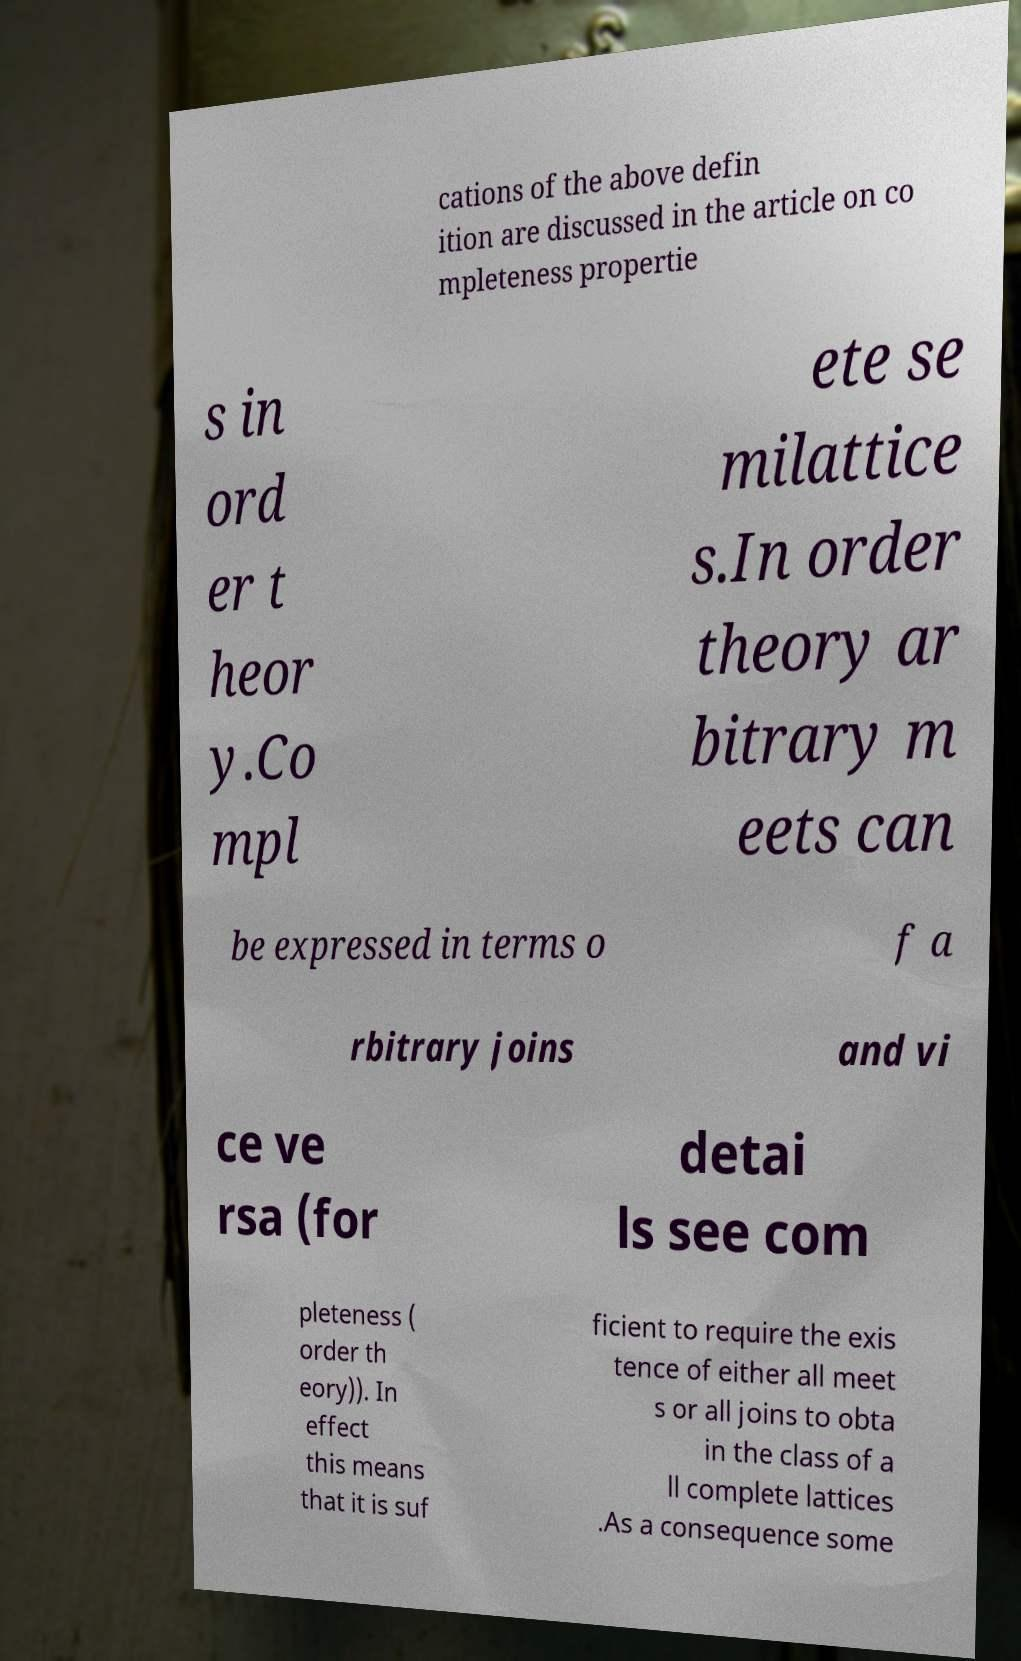For documentation purposes, I need the text within this image transcribed. Could you provide that? cations of the above defin ition are discussed in the article on co mpleteness propertie s in ord er t heor y.Co mpl ete se milattice s.In order theory ar bitrary m eets can be expressed in terms o f a rbitrary joins and vi ce ve rsa (for detai ls see com pleteness ( order th eory)). In effect this means that it is suf ficient to require the exis tence of either all meet s or all joins to obta in the class of a ll complete lattices .As a consequence some 